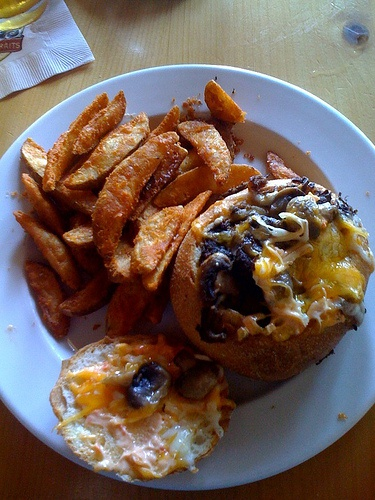Describe the objects in this image and their specific colors. I can see dining table in olive, maroon, black, and darkgray tones and sandwich in olive, black, and maroon tones in this image. 